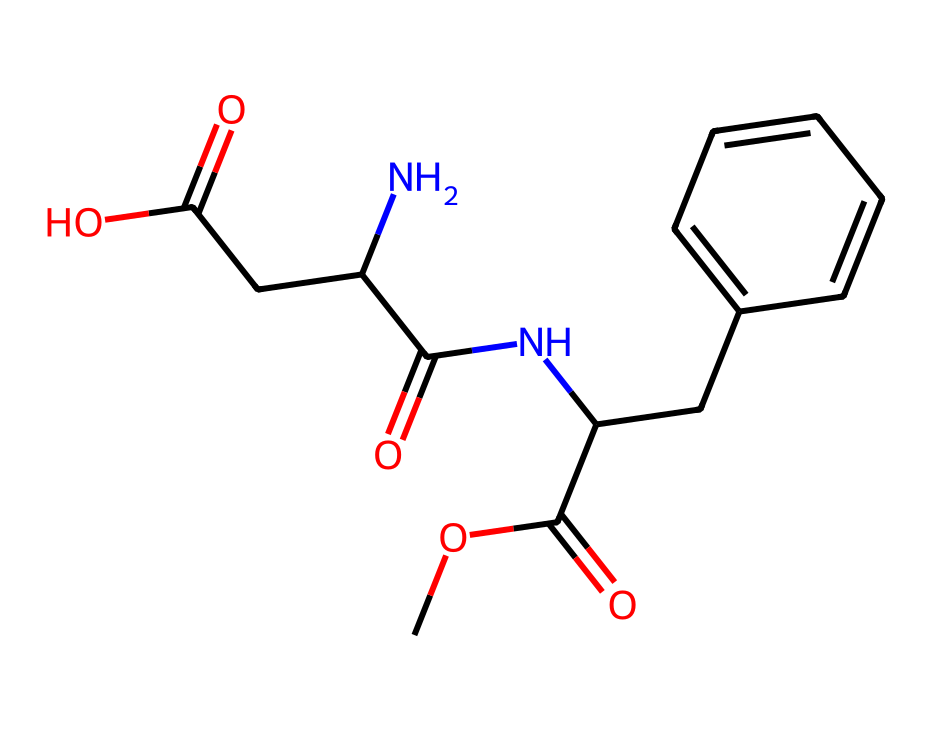What is the molecular formula of aspartame? To find the molecular formula, count the number of each type of atom in the structure based on the SMILES notation. The atoms present are: Carbon (C), Hydrogen (H), Nitrogen (N), and Oxygen (O). In total, there are 14 Carbons, 18 Hydrogens, 2 Nitrogens, and 5 Oxygens. Thus, the molecular formula is C14H18N2O5.
Answer: C14H18N2O5 How many rings are present in aspartame? Examining the chemical structure, we note that rings are typically identified by circles or fusion of bonds. In the provided structure, there is a phenyl ring (six-membered) attached to the rest of the molecule, indicating that there is 1 ring present.
Answer: 1 What functional groups are present in aspartame? By analyzing the structure, we can identify key functional groups: a carboxylic acid group (–COOH), an amide group (–C(=O)N–), and an ester group (–COOC–). These functional groups highlight its chemical reactivity and properties.
Answer: carboxylic acid, amide, ester What is the number of nitrogen atoms in aspartame? The SMILES notation indicates nitrogen atoms with the "N" symbol. By counting them in the structure, we find there are 2 nitrogen atoms present in aspartame.
Answer: 2 Which part of aspartame contributes to its sweetness? The sweetness of aspartame primarily comes from the amine functional groups combined with the aromatic character of the ring, which plays a role in the sensory perception of sweetness.
Answer: amine groups What is the solubility characteristic of aspartame? Aspartame is a non-electrolyte, indicating that it does not dissociate into ions in solution. This property is largely tied to the presence of its functional groups and its overall molecular structure, which is predominantly covalent.
Answer: non-electrolyte 